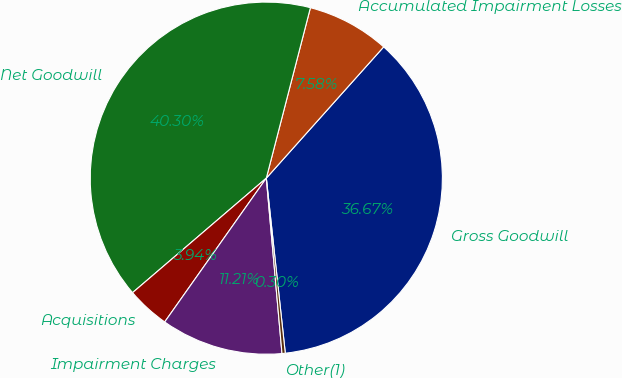<chart> <loc_0><loc_0><loc_500><loc_500><pie_chart><fcel>Gross Goodwill<fcel>Accumulated Impairment Losses<fcel>Net Goodwill<fcel>Acquisitions<fcel>Impairment Charges<fcel>Other(1)<nl><fcel>36.67%<fcel>7.58%<fcel>40.3%<fcel>3.94%<fcel>11.21%<fcel>0.3%<nl></chart> 